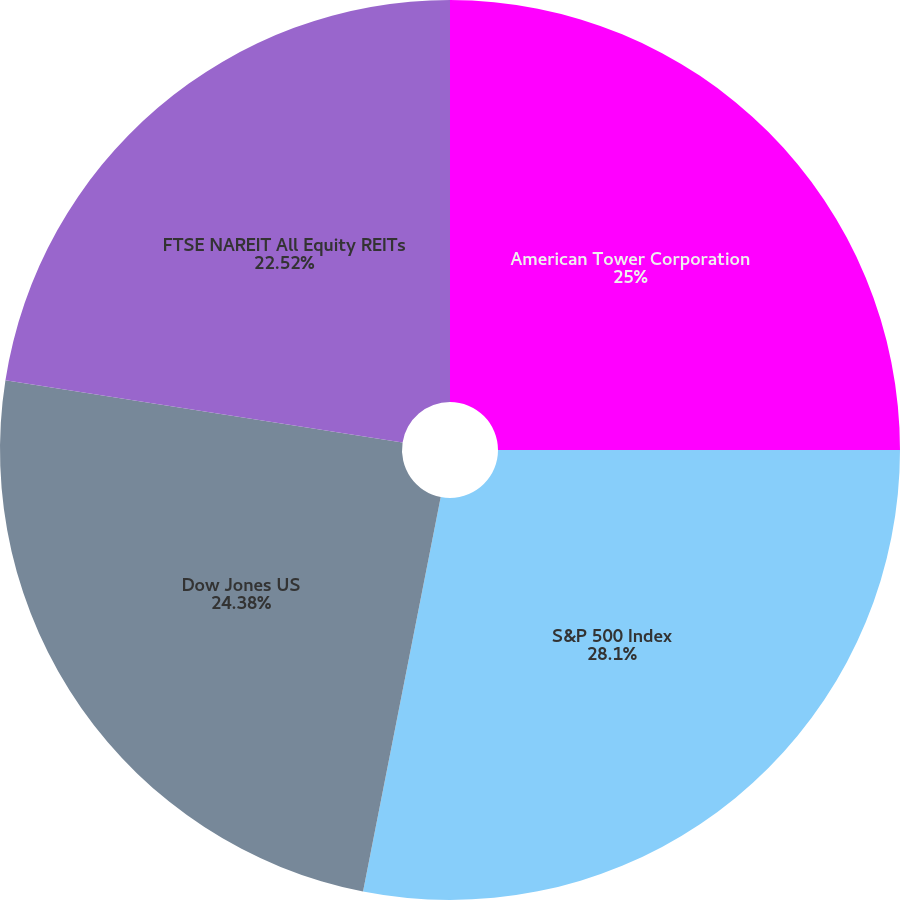Convert chart. <chart><loc_0><loc_0><loc_500><loc_500><pie_chart><fcel>American Tower Corporation<fcel>S&P 500 Index<fcel>Dow Jones US<fcel>FTSE NAREIT All Equity REITs<nl><fcel>25.0%<fcel>28.09%<fcel>24.38%<fcel>22.52%<nl></chart> 